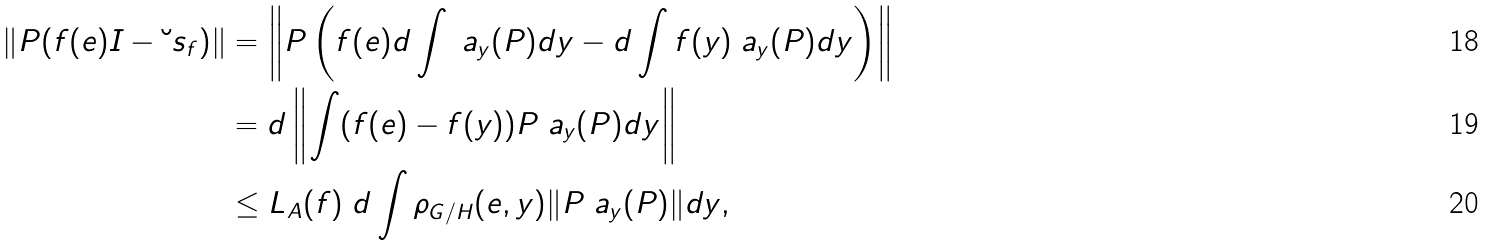<formula> <loc_0><loc_0><loc_500><loc_500>\| P ( f ( e ) I - { \breve { \ } s } _ { f } ) \| & = \left \| P \left ( f ( e ) d \int \ a _ { y } ( P ) d y - d \int f ( y ) \ a _ { y } ( P ) d y \right ) \right \| \\ & = d \left \| \int ( f ( e ) - f ( y ) ) P \ a _ { y } ( P ) d y \right \| \\ & \leq L _ { A } ( f ) \ d \int \rho _ { G / H } ( e , y ) \| P \ a _ { y } ( P ) \| d y ,</formula> 